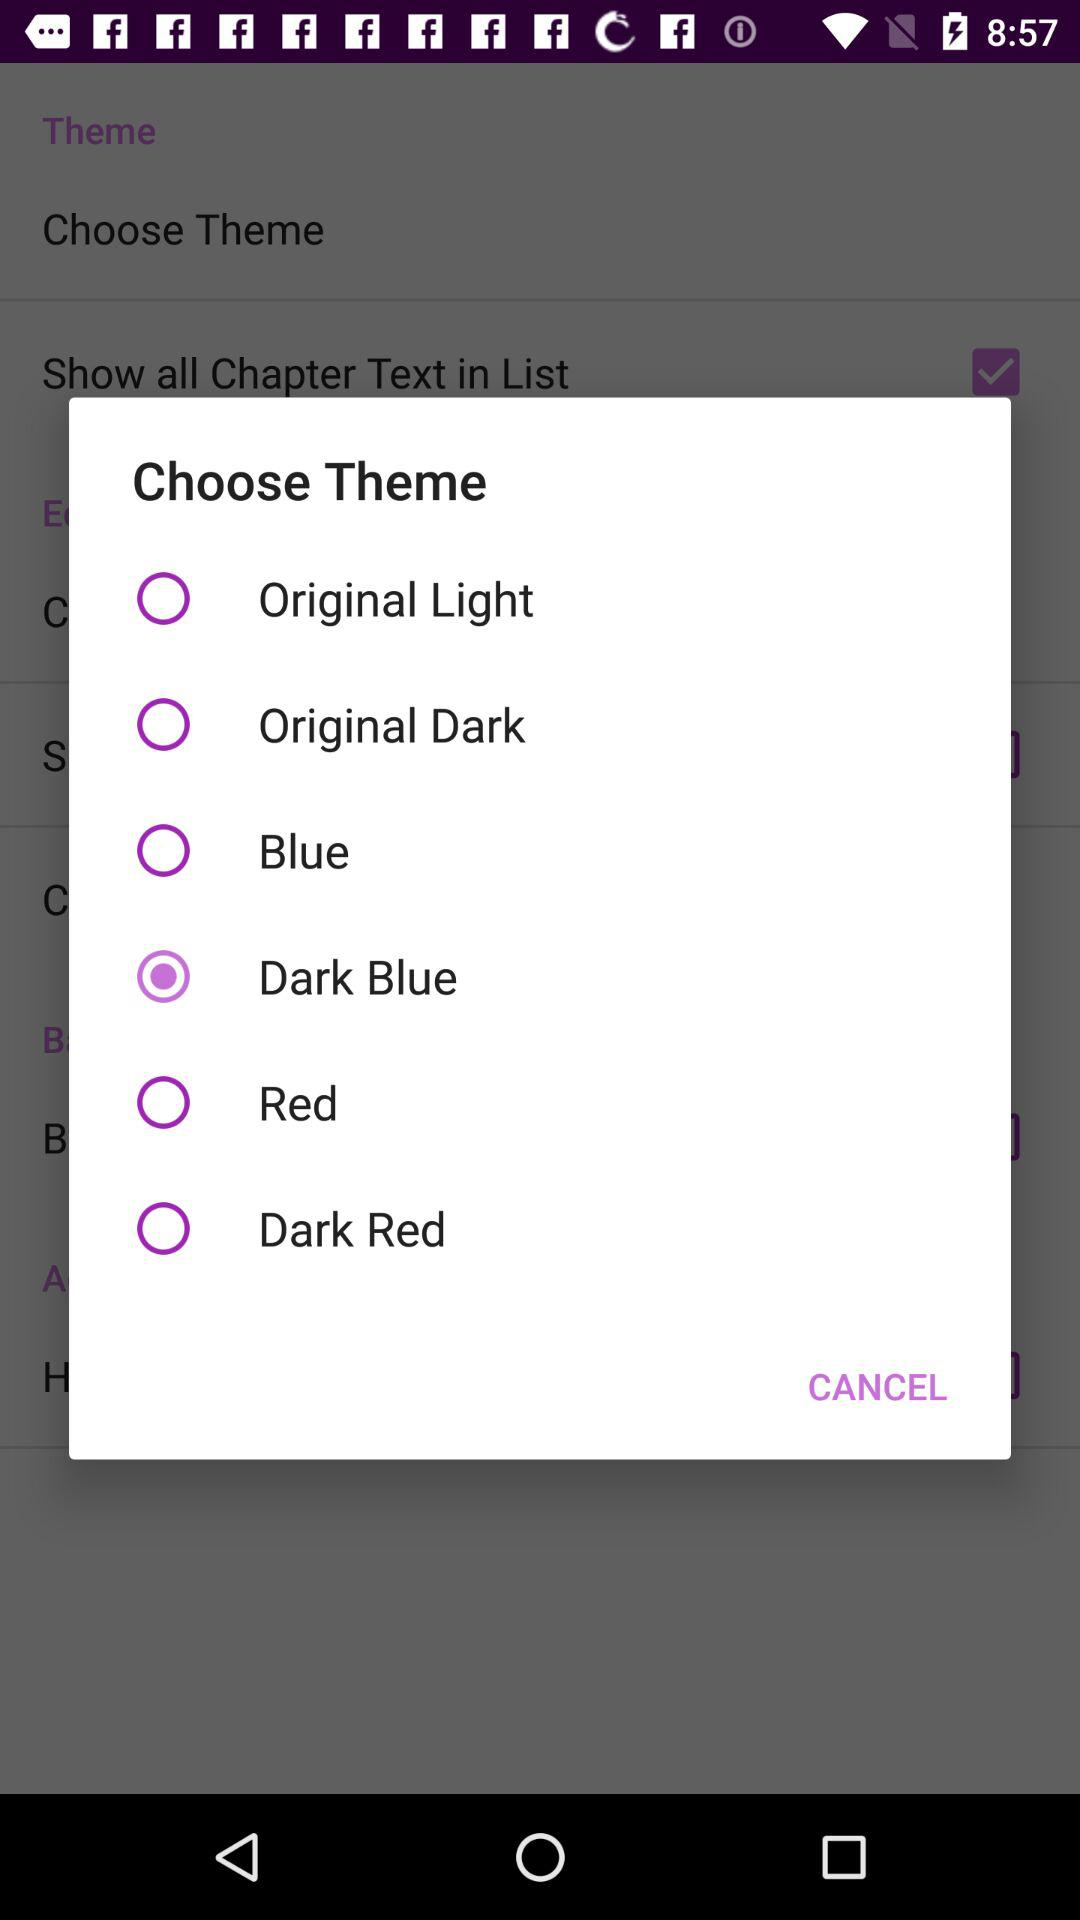Which theme is selected? The selected theme is "Dark Blue". 